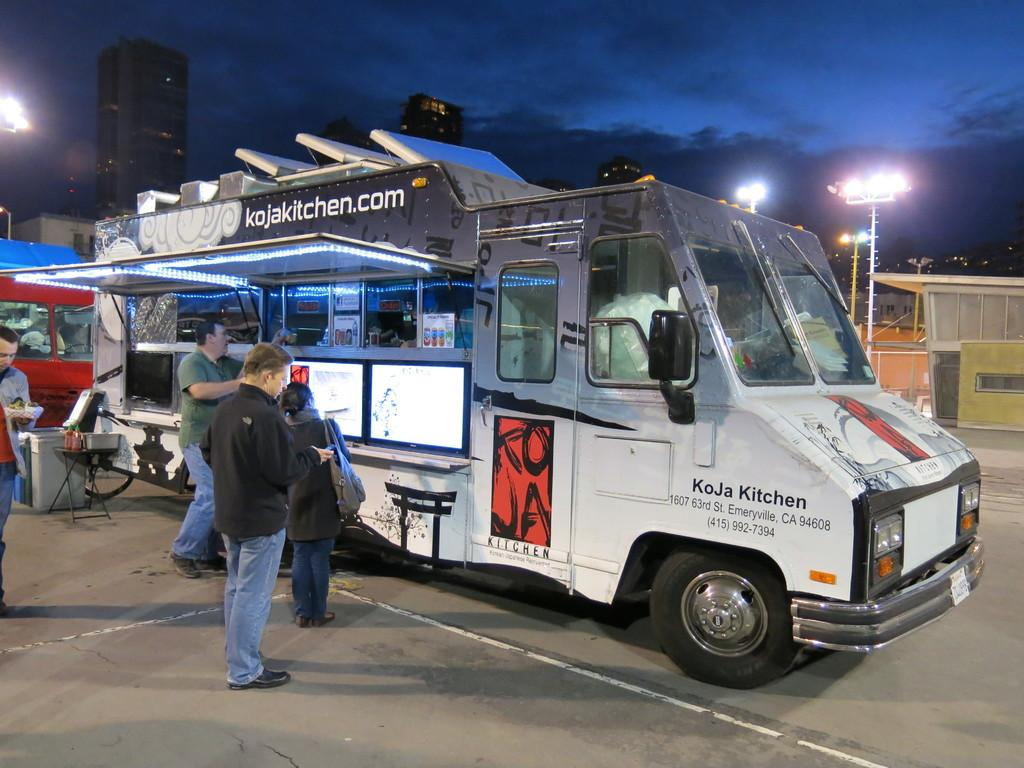Provide a one-sentence caption for the provided image. People  in line to get food from the KoJa Kitchen food truck at night. 